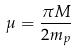Convert formula to latex. <formula><loc_0><loc_0><loc_500><loc_500>\mu = \frac { \pi M } { 2 m _ { p } }</formula> 